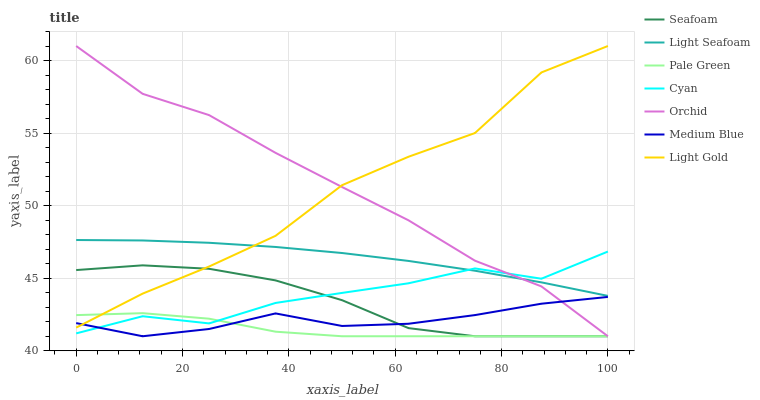Does Seafoam have the minimum area under the curve?
Answer yes or no. No. Does Seafoam have the maximum area under the curve?
Answer yes or no. No. Is Seafoam the smoothest?
Answer yes or no. No. Is Seafoam the roughest?
Answer yes or no. No. Does Cyan have the lowest value?
Answer yes or no. No. Does Seafoam have the highest value?
Answer yes or no. No. Is Cyan less than Light Gold?
Answer yes or no. Yes. Is Light Gold greater than Cyan?
Answer yes or no. Yes. Does Cyan intersect Light Gold?
Answer yes or no. No. 